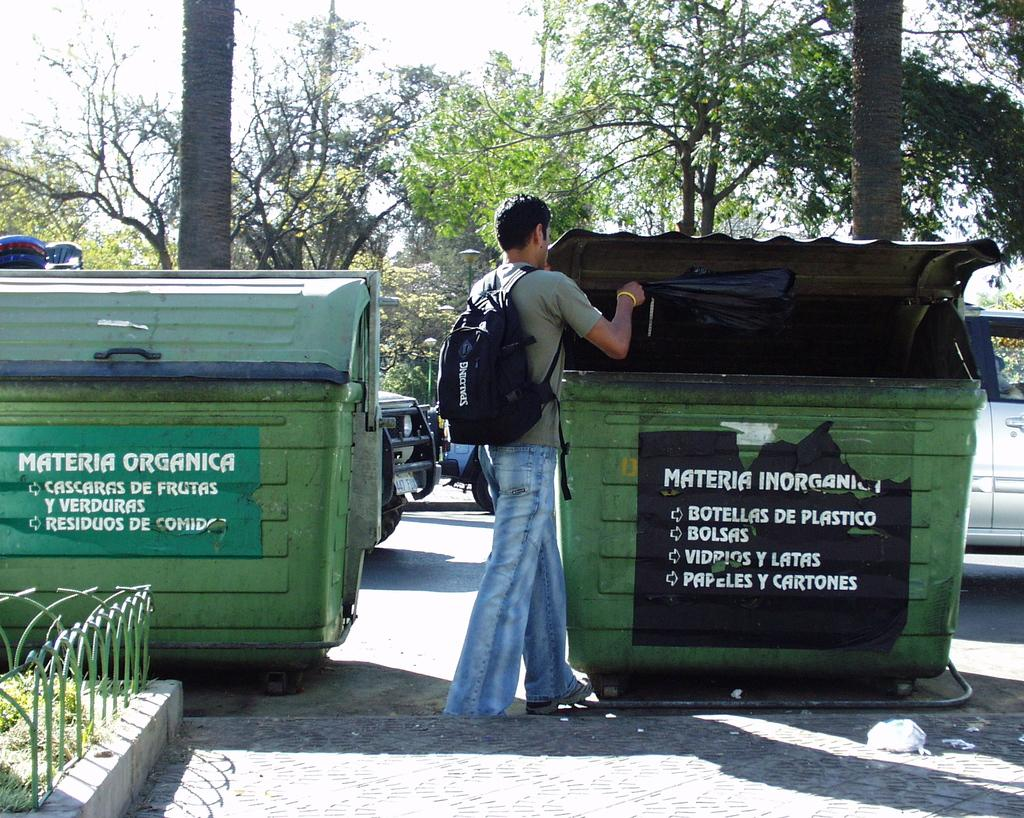Provide a one-sentence caption for the provided image. A young male drops waste into a dumpster labelled as accepting bolsas. 